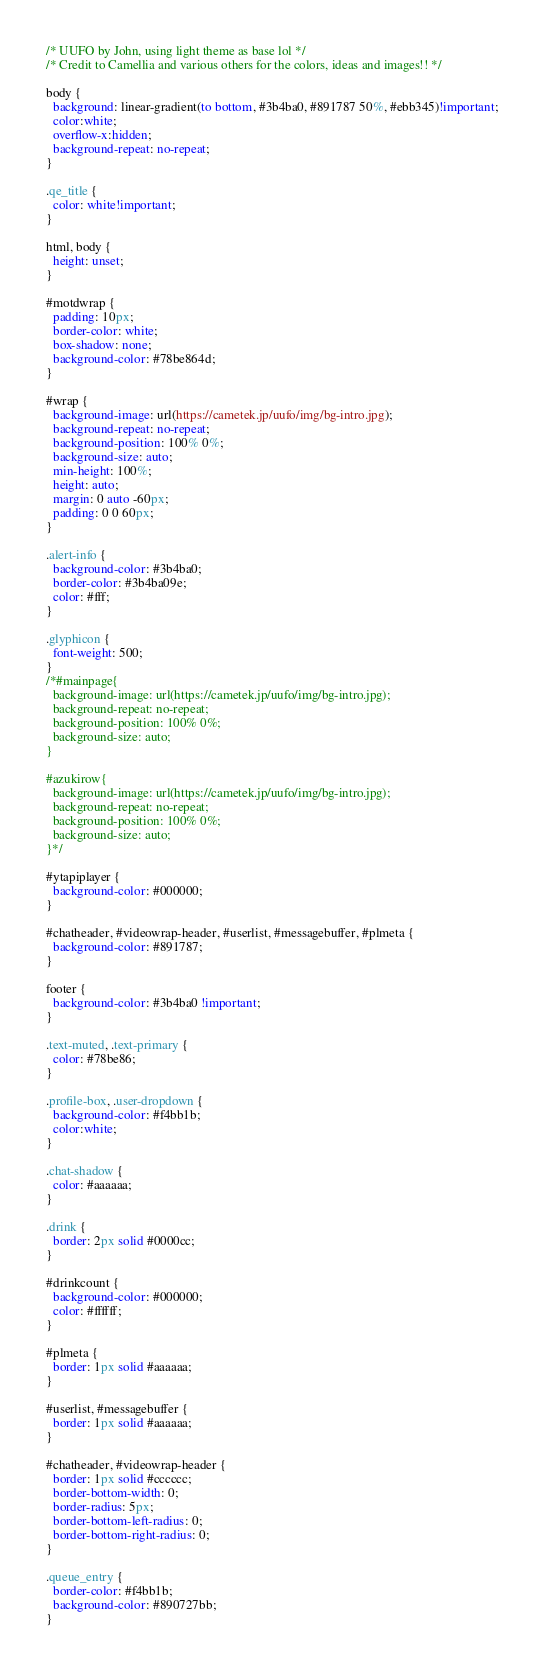Convert code to text. <code><loc_0><loc_0><loc_500><loc_500><_CSS_>/* UUFO by John, using light theme as base lol */
/* Credit to Camellia and various others for the colors, ideas and images!! */

body {
  background: linear-gradient(to bottom, #3b4ba0, #891787 50%, #ebb345)!important;
  color:white;
  overflow-x:hidden;
  background-repeat: no-repeat;
}

.qe_title {
  color: white!important;
}

html, body {
  height: unset;
}

#motdwrap {
  padding: 10px;
  border-color: white;
  box-shadow: none;
  background-color: #78be864d;
}

#wrap {
  background-image: url(https://cametek.jp/uufo/img/bg-intro.jpg);
  background-repeat: no-repeat;
  background-position: 100% 0%;
  background-size: auto;
  min-height: 100%;
  height: auto;
  margin: 0 auto -60px;
  padding: 0 0 60px;
}

.alert-info {
  background-color: #3b4ba0;
  border-color: #3b4ba09e;
  color: #fff;
}

.glyphicon {
  font-weight: 500;
}
/*#mainpage{
  background-image: url(https://cametek.jp/uufo/img/bg-intro.jpg);
  background-repeat: no-repeat;
  background-position: 100% 0%;
  background-size: auto;
}

#azukirow{
  background-image: url(https://cametek.jp/uufo/img/bg-intro.jpg);
  background-repeat: no-repeat;
  background-position: 100% 0%;
  background-size: auto;
}*/

#ytapiplayer {
  background-color: #000000;
}

#chatheader, #videowrap-header, #userlist, #messagebuffer, #plmeta {
  background-color: #891787;
}

footer {
  background-color: #3b4ba0 !important;
}

.text-muted, .text-primary {
  color: #78be86;
}

.profile-box, .user-dropdown {
  background-color: #f4bb1b;
  color:white;
}

.chat-shadow {
  color: #aaaaaa;
}

.drink {
  border: 2px solid #0000cc;
}

#drinkcount {
  background-color: #000000;
  color: #ffffff;
}

#plmeta {
  border: 1px solid #aaaaaa;
}

#userlist, #messagebuffer {
  border: 1px solid #aaaaaa;
}

#chatheader, #videowrap-header {
  border: 1px solid #cccccc;
  border-bottom-width: 0;
  border-radius: 5px;
  border-bottom-left-radius: 0;
  border-bottom-right-radius: 0;
}

.queue_entry {
  border-color: #f4bb1b;
  background-color: #890727bb;
}
</code> 